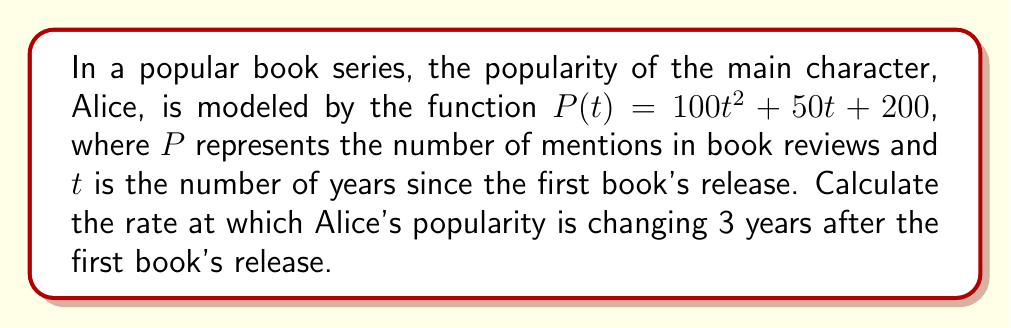Give your solution to this math problem. To find the rate at which Alice's popularity is changing, we need to calculate the derivative of the given function and then evaluate it at $t = 3$. Let's break this down step-by-step:

1. Given function: $P(t) = 100t^2 + 50t + 200$

2. To find the rate of change, we need to calculate $\frac{dP}{dt}$:
   
   $\frac{dP}{dt} = \frac{d}{dt}(100t^2 + 50t + 200)$

3. Using the power rule and constant rule of differentiation:
   
   $\frac{dP}{dt} = 100 \cdot 2t + 50 + 0$
   
   $\frac{dP}{dt} = 200t + 50$

4. Now that we have the derivative, we can evaluate it at $t = 3$:
   
   $\frac{dP}{dt}|_{t=3} = 200(3) + 50$
   
   $\frac{dP}{dt}|_{t=3} = 600 + 50 = 650$

Therefore, 3 years after the first book's release, Alice's popularity is changing at a rate of 650 mentions per year.
Answer: 650 mentions per year 